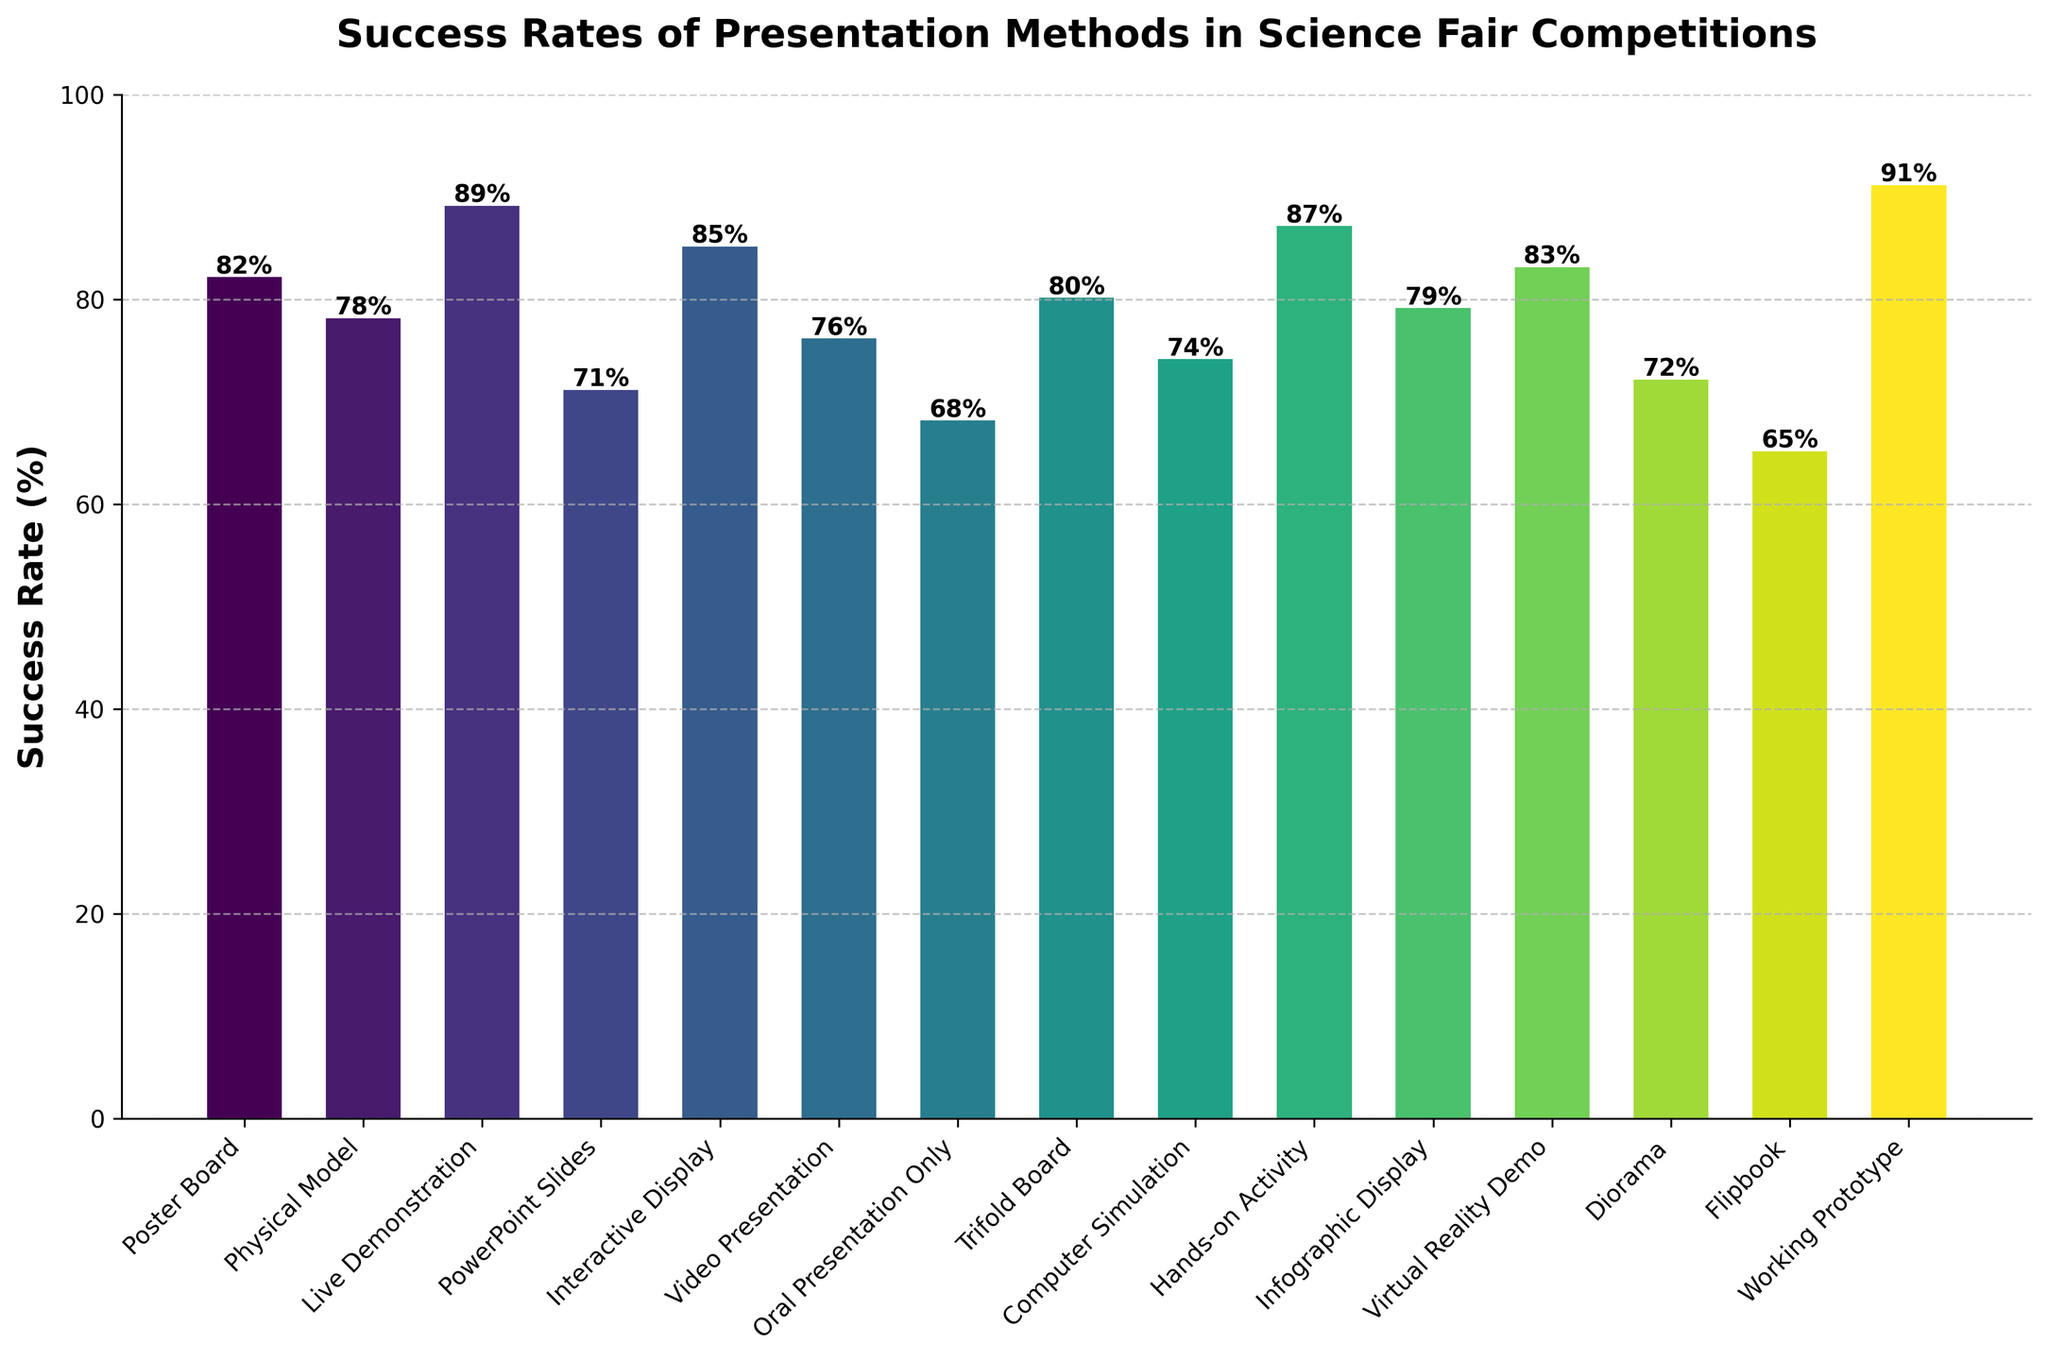What is the highest success rate among the presentation methods? Look for the tallest bar in the figure. The label on top shows the value.
Answer: 91% Which method has a higher success rate, Oral Presentation Only or Trifold Board? Compare the heights of the bars and their labels for Oral Presentation Only and Trifold Board.
Answer: Trifold Board How does the success rate of Interactive Display compare to Video Presentation? Find their respective bars for Interactive Display and Video Presentation and compare their heights and labels.
Answer: Interactive Display is higher What is the average success rate of PowerPoint Slides, Video Presentation, and Infographic Display? Add the success rates (71 + 76 + 79) and then divide by the number of methods (3). The calculation is (71 + 76 + 79) / 3 = 226 / 3 ≈ 75.3.
Answer: 75.3 Which presentation methods have a success rate above 80%? Identify the bars that have values above 80%.
Answer: Poster Board, Live Demonstration, Interactive Display, Hands-on Activity, Virtual Reality Demo, Working Prototype What is the difference in success rate between Physical Model and Computer Simulation? Subtract the success rate of Computer Simulation from Physical Model (78 - 74).
Answer: 4 How many methods have success rates below 70%? Count the number of bars with values less than 70%.
Answer: Two How does the color change across the presentation methods? Observe the gradient of colors used in the figure.
Answer: Color changes from one end of the viridis color map to the other Which method has the lowest success rate and what is it? Identify the shortest bar and check the label on top.
Answer: Flipbook, 65% What is the total success rate if you sum up Poster Board, Live Demonstration, and Hands-on Activity? Add the success rates of these methods (82 + 89 + 87). The calculation is 82 + 89 + 87 = 258.
Answer: 258 